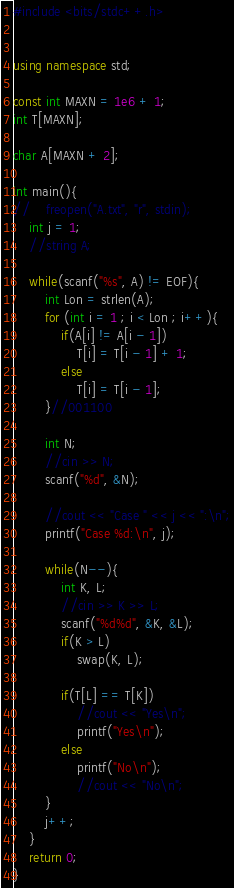<code> <loc_0><loc_0><loc_500><loc_500><_C++_>#include <bits/stdc++.h>


using namespace std;

const int MAXN = 1e6 + 1;
int T[MAXN];

char A[MAXN + 2];

int main(){
//    freopen("A.txt", "r", stdin);
    int j = 1;
    //string A;

    while(scanf("%s", A) != EOF){
        int Lon = strlen(A);
        for (int i = 1 ; i < Lon ; i++){
            if(A[i] != A[i - 1])
                T[i] = T[i - 1] + 1;
            else
                T[i] = T[i - 1];
        }//001100

        int N;
        //cin >> N;
        scanf("%d", &N);

        //cout << "Case " << j << ":\n";
        printf("Case %d:\n", j);

        while(N--){
            int K, L;
            //cin >> K >> L;
            scanf("%d%d", &K, &L);
            if(K > L)
                swap(K, L);

            if(T[L] == T[K])
                //cout << "Yes\n";
                printf("Yes\n");
            else
                printf("No\n");
                //cout << "No\n";
        }
        j++;
    }
	return 0;
}
</code> 